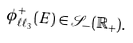Convert formula to latex. <formula><loc_0><loc_0><loc_500><loc_500>\phi ^ { + } _ { \ell \ell _ { 3 } } ( E ) \in \mathcal { S } _ { - } ( \mathbb { R } _ { + } ) .</formula> 